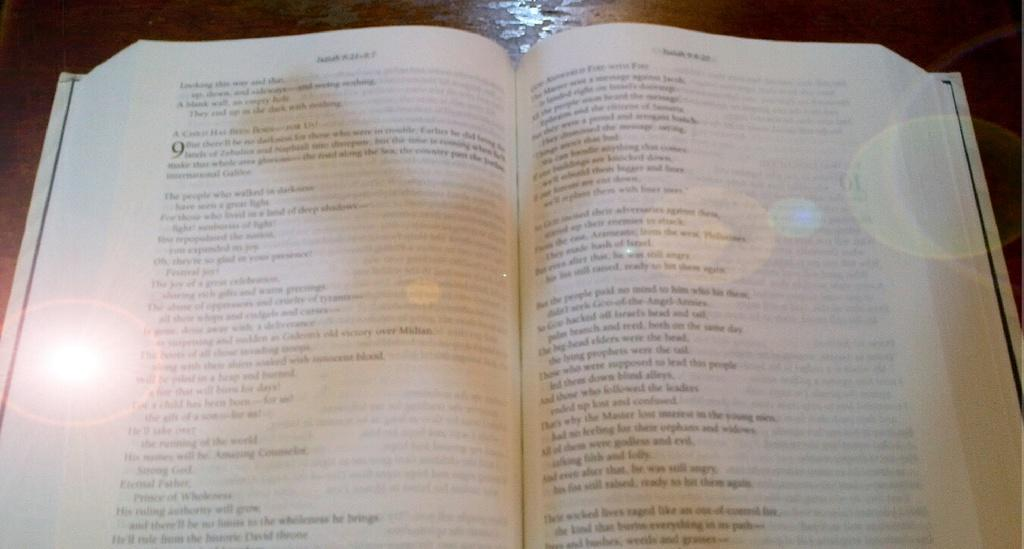What object can be seen in the image? There is a book in the image. Where is the book located? The book is on a table. What can be found on the book? There is text on the book. How many ants are crawling on the book in the image? There are no ants present in the image. What type of print is visible on the book? The provided facts do not mention any specific type of print on the book. 